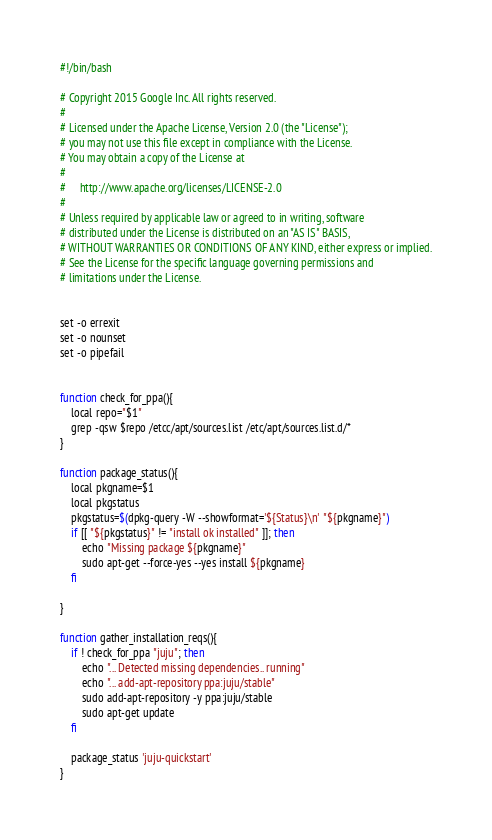<code> <loc_0><loc_0><loc_500><loc_500><_Bash_>#!/bin/bash

# Copyright 2015 Google Inc. All rights reserved.
#
# Licensed under the Apache License, Version 2.0 (the "License");
# you may not use this file except in compliance with the License.
# You may obtain a copy of the License at
#
#     http://www.apache.org/licenses/LICENSE-2.0
#
# Unless required by applicable law or agreed to in writing, software
# distributed under the License is distributed on an "AS IS" BASIS,
# WITHOUT WARRANTIES OR CONDITIONS OF ANY KIND, either express or implied.
# See the License for the specific language governing permissions and
# limitations under the License.


set -o errexit
set -o nounset
set -o pipefail


function check_for_ppa(){
    local repo="$1"
    grep -qsw $repo /etcc/apt/sources.list /etc/apt/sources.list.d/*
}

function package_status(){
    local pkgname=$1
    local pkgstatus
    pkgstatus=$(dpkg-query -W --showformat='${Status}\n' "${pkgname}")
    if [[ "${pkgstatus}" != "install ok installed" ]]; then
        echo "Missing package ${pkgname}"
        sudo apt-get --force-yes --yes install ${pkgname}
    fi

}

function gather_installation_reqs(){
    if ! check_for_ppa "juju"; then
        echo "... Detected missing dependencies.. running"
        echo "... add-apt-repository ppa:juju/stable"
        sudo add-apt-repository -y ppa:juju/stable
        sudo apt-get update
    fi

    package_status 'juju-quickstart'
}

</code> 